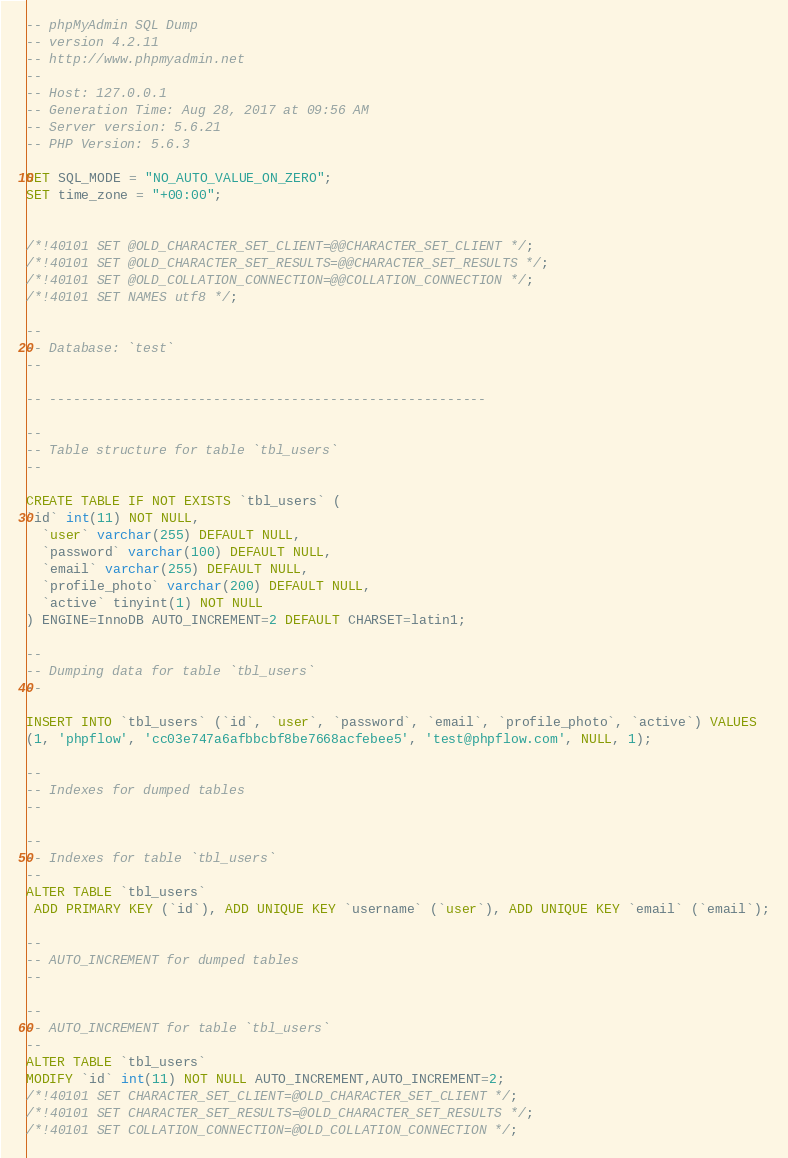<code> <loc_0><loc_0><loc_500><loc_500><_SQL_>-- phpMyAdmin SQL Dump
-- version 4.2.11
-- http://www.phpmyadmin.net
--
-- Host: 127.0.0.1
-- Generation Time: Aug 28, 2017 at 09:56 AM
-- Server version: 5.6.21
-- PHP Version: 5.6.3

SET SQL_MODE = "NO_AUTO_VALUE_ON_ZERO";
SET time_zone = "+00:00";


/*!40101 SET @OLD_CHARACTER_SET_CLIENT=@@CHARACTER_SET_CLIENT */;
/*!40101 SET @OLD_CHARACTER_SET_RESULTS=@@CHARACTER_SET_RESULTS */;
/*!40101 SET @OLD_COLLATION_CONNECTION=@@COLLATION_CONNECTION */;
/*!40101 SET NAMES utf8 */;

--
-- Database: `test`
--

-- --------------------------------------------------------

--
-- Table structure for table `tbl_users`
--

CREATE TABLE IF NOT EXISTS `tbl_users` (
`id` int(11) NOT NULL,
  `user` varchar(255) DEFAULT NULL,
  `password` varchar(100) DEFAULT NULL,
  `email` varchar(255) DEFAULT NULL,
  `profile_photo` varchar(200) DEFAULT NULL,
  `active` tinyint(1) NOT NULL
) ENGINE=InnoDB AUTO_INCREMENT=2 DEFAULT CHARSET=latin1;

--
-- Dumping data for table `tbl_users`
--

INSERT INTO `tbl_users` (`id`, `user`, `password`, `email`, `profile_photo`, `active`) VALUES
(1, 'phpflow', 'cc03e747a6afbbcbf8be7668acfebee5', 'test@phpflow.com', NULL, 1);

--
-- Indexes for dumped tables
--

--
-- Indexes for table `tbl_users`
--
ALTER TABLE `tbl_users`
 ADD PRIMARY KEY (`id`), ADD UNIQUE KEY `username` (`user`), ADD UNIQUE KEY `email` (`email`);

--
-- AUTO_INCREMENT for dumped tables
--

--
-- AUTO_INCREMENT for table `tbl_users`
--
ALTER TABLE `tbl_users`
MODIFY `id` int(11) NOT NULL AUTO_INCREMENT,AUTO_INCREMENT=2;
/*!40101 SET CHARACTER_SET_CLIENT=@OLD_CHARACTER_SET_CLIENT */;
/*!40101 SET CHARACTER_SET_RESULTS=@OLD_CHARACTER_SET_RESULTS */;
/*!40101 SET COLLATION_CONNECTION=@OLD_COLLATION_CONNECTION */;
</code> 